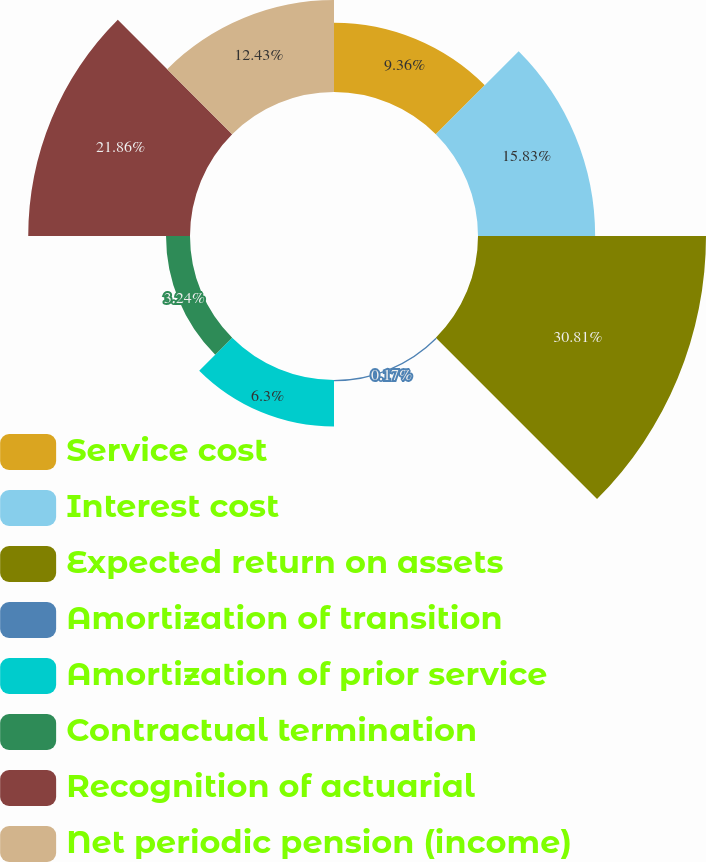Convert chart to OTSL. <chart><loc_0><loc_0><loc_500><loc_500><pie_chart><fcel>Service cost<fcel>Interest cost<fcel>Expected return on assets<fcel>Amortization of transition<fcel>Amortization of prior service<fcel>Contractual termination<fcel>Recognition of actuarial<fcel>Net periodic pension (income)<nl><fcel>9.36%<fcel>15.83%<fcel>30.81%<fcel>0.17%<fcel>6.3%<fcel>3.24%<fcel>21.86%<fcel>12.43%<nl></chart> 